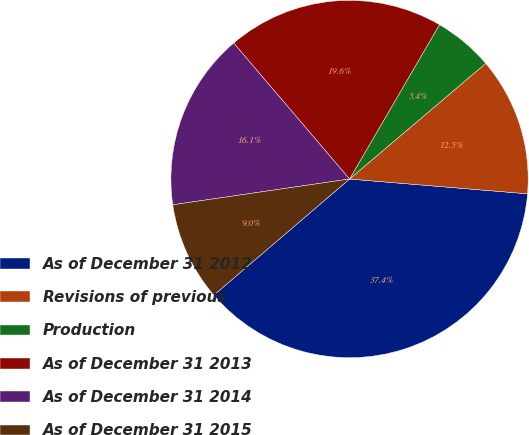Convert chart to OTSL. <chart><loc_0><loc_0><loc_500><loc_500><pie_chart><fcel>As of December 31 2012<fcel>Revisions of previous<fcel>Production<fcel>As of December 31 2013<fcel>As of December 31 2014<fcel>As of December 31 2015<nl><fcel>37.42%<fcel>12.52%<fcel>5.4%<fcel>19.63%<fcel>16.07%<fcel>8.96%<nl></chart> 